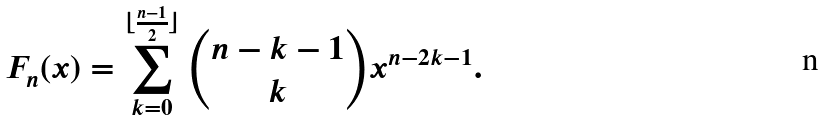Convert formula to latex. <formula><loc_0><loc_0><loc_500><loc_500>F _ { n } ( x ) = \sum _ { k = 0 } ^ { \lfloor \frac { n - 1 } { 2 } \rfloor } { n - k - 1 \choose k } x ^ { n - 2 k - 1 } .</formula> 